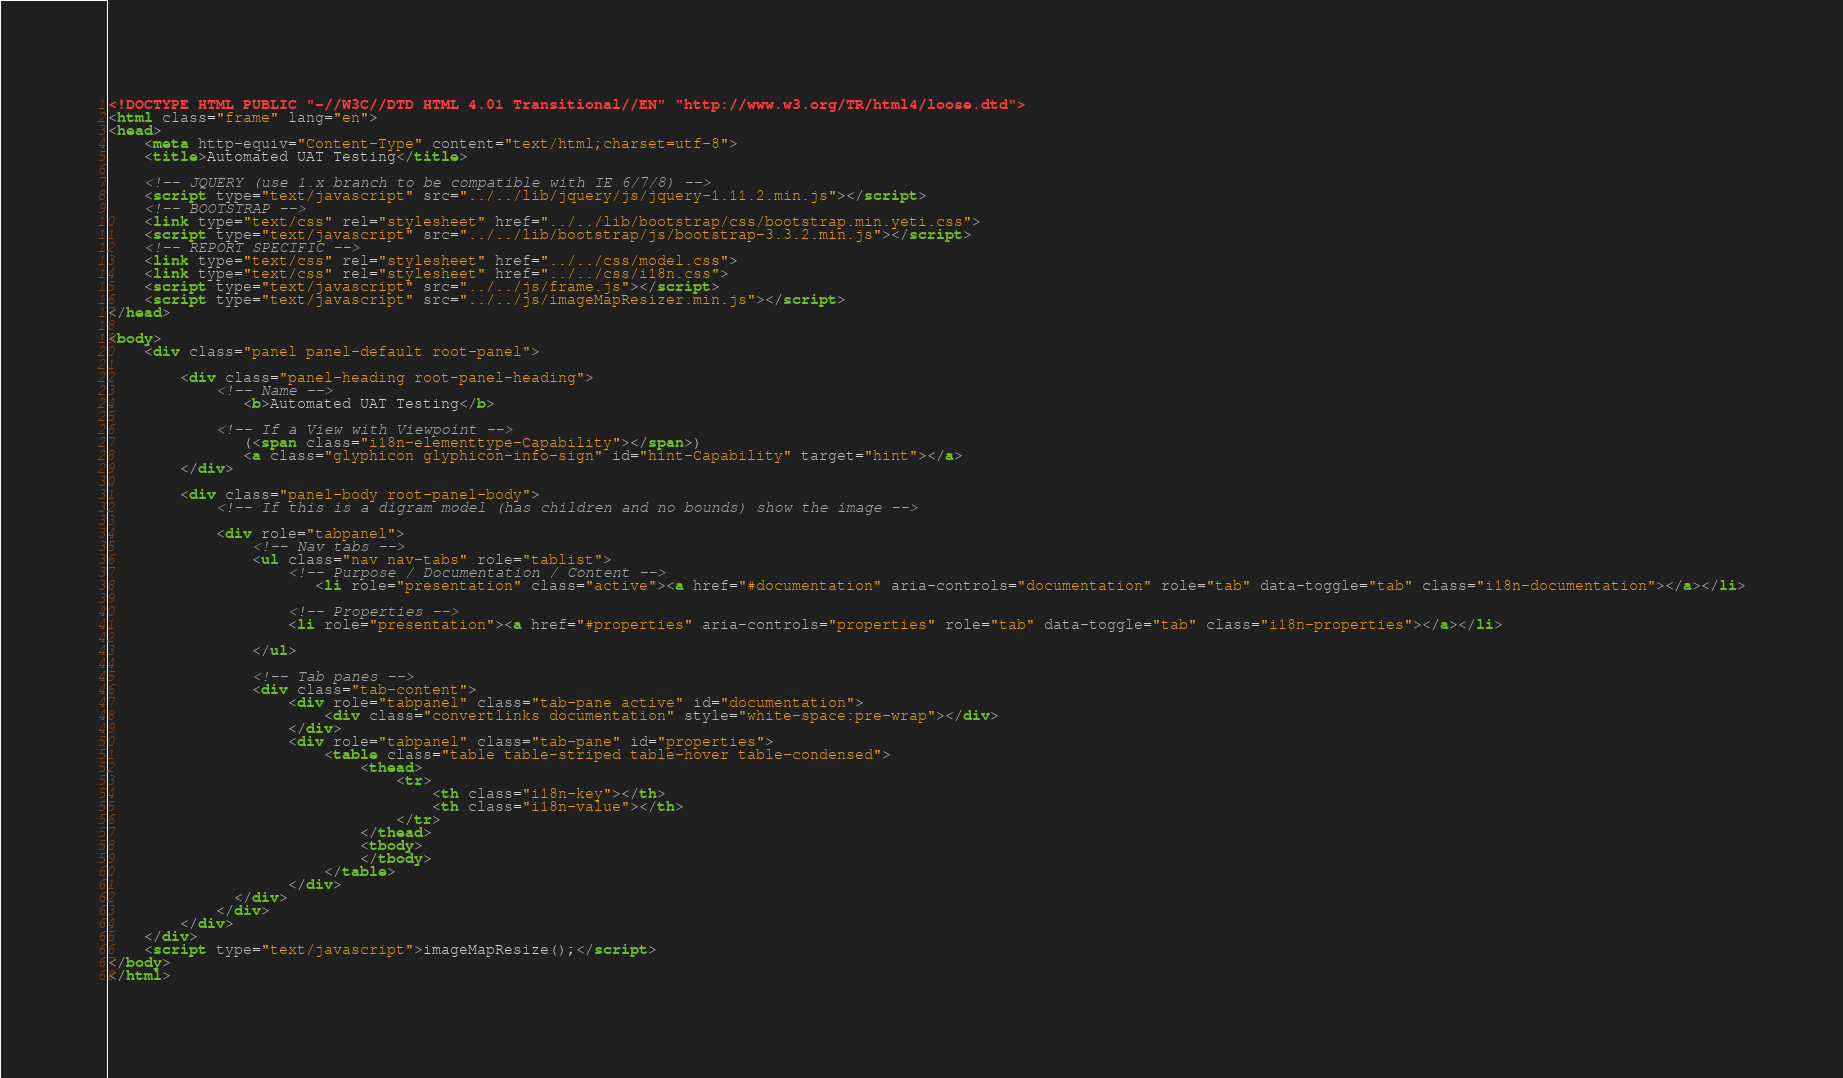<code> <loc_0><loc_0><loc_500><loc_500><_HTML_><!DOCTYPE HTML PUBLIC "-//W3C//DTD HTML 4.01 Transitional//EN" "http://www.w3.org/TR/html4/loose.dtd">
<html class="frame" lang="en">
<head>
	<meta http-equiv="Content-Type" content="text/html;charset=utf-8">
	<title>Automated UAT Testing</title>

	<!-- JQUERY (use 1.x branch to be compatible with IE 6/7/8) -->
	<script type="text/javascript" src="../../lib/jquery/js/jquery-1.11.2.min.js"></script>
	<!-- BOOTSTRAP -->
	<link type="text/css" rel="stylesheet" href="../../lib/bootstrap/css/bootstrap.min.yeti.css">
	<script type="text/javascript" src="../../lib/bootstrap/js/bootstrap-3.3.2.min.js"></script>
	<!-- REPORT SPECIFIC -->
	<link type="text/css" rel="stylesheet" href="../../css/model.css">
	<link type="text/css" rel="stylesheet" href="../../css/i18n.css">
	<script type="text/javascript" src="../../js/frame.js"></script>
	<script type="text/javascript" src="../../js/imageMapResizer.min.js"></script>
</head>

<body>
	<div class="panel panel-default root-panel">

		<div class="panel-heading root-panel-heading">
            <!-- Name -->
               <b>Automated UAT Testing</b>

            <!-- If a View with Viewpoint -->
			   (<span class="i18n-elementtype-Capability"></span>)
			   <a class="glyphicon glyphicon-info-sign" id="hint-Capability" target="hint"></a>
		</div>

		<div class="panel-body root-panel-body">
		    <!-- If this is a digram model (has children and no bounds) show the image -->

			<div role="tabpanel">
				<!-- Nav tabs -->
				<ul class="nav nav-tabs" role="tablist">
                    <!-- Purpose / Documentation / Content -->
					   <li role="presentation" class="active"><a href="#documentation" aria-controls="documentation" role="tab" data-toggle="tab" class="i18n-documentation"></a></li>

                    <!-- Properties -->
                    <li role="presentation"><a href="#properties" aria-controls="properties" role="tab" data-toggle="tab" class="i18n-properties"></a></li>

				</ul>

				<!-- Tab panes -->
				<div class="tab-content">
					<div role="tabpanel" class="tab-pane active" id="documentation">
						<div class="convertlinks documentation" style="white-space:pre-wrap"></div>
					</div>
					<div role="tabpanel" class="tab-pane" id="properties">
						<table class="table table-striped table-hover table-condensed">
							<thead>
								<tr>
									<th class="i18n-key"></th>
									<th class="i18n-value"></th>
								</tr>
							</thead>
							<tbody>
							</tbody>
						</table>
					</div>
			  </div>
			</div>
		</div>
	</div>
	<script type="text/javascript">imageMapResize();</script>
</body>
</html></code> 